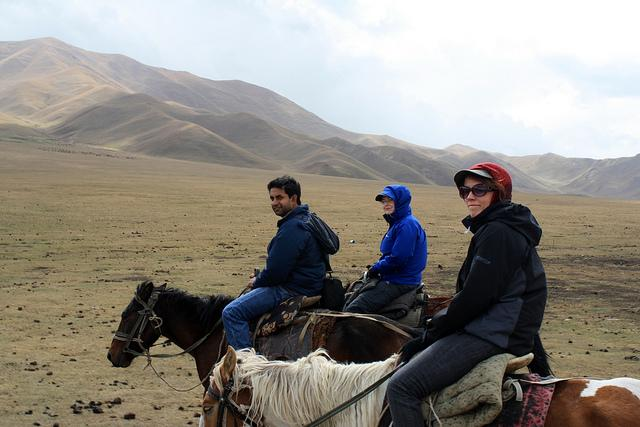What are the people turning to look at?

Choices:
A) animal
B) camera
C) sea
D) traffic camera 